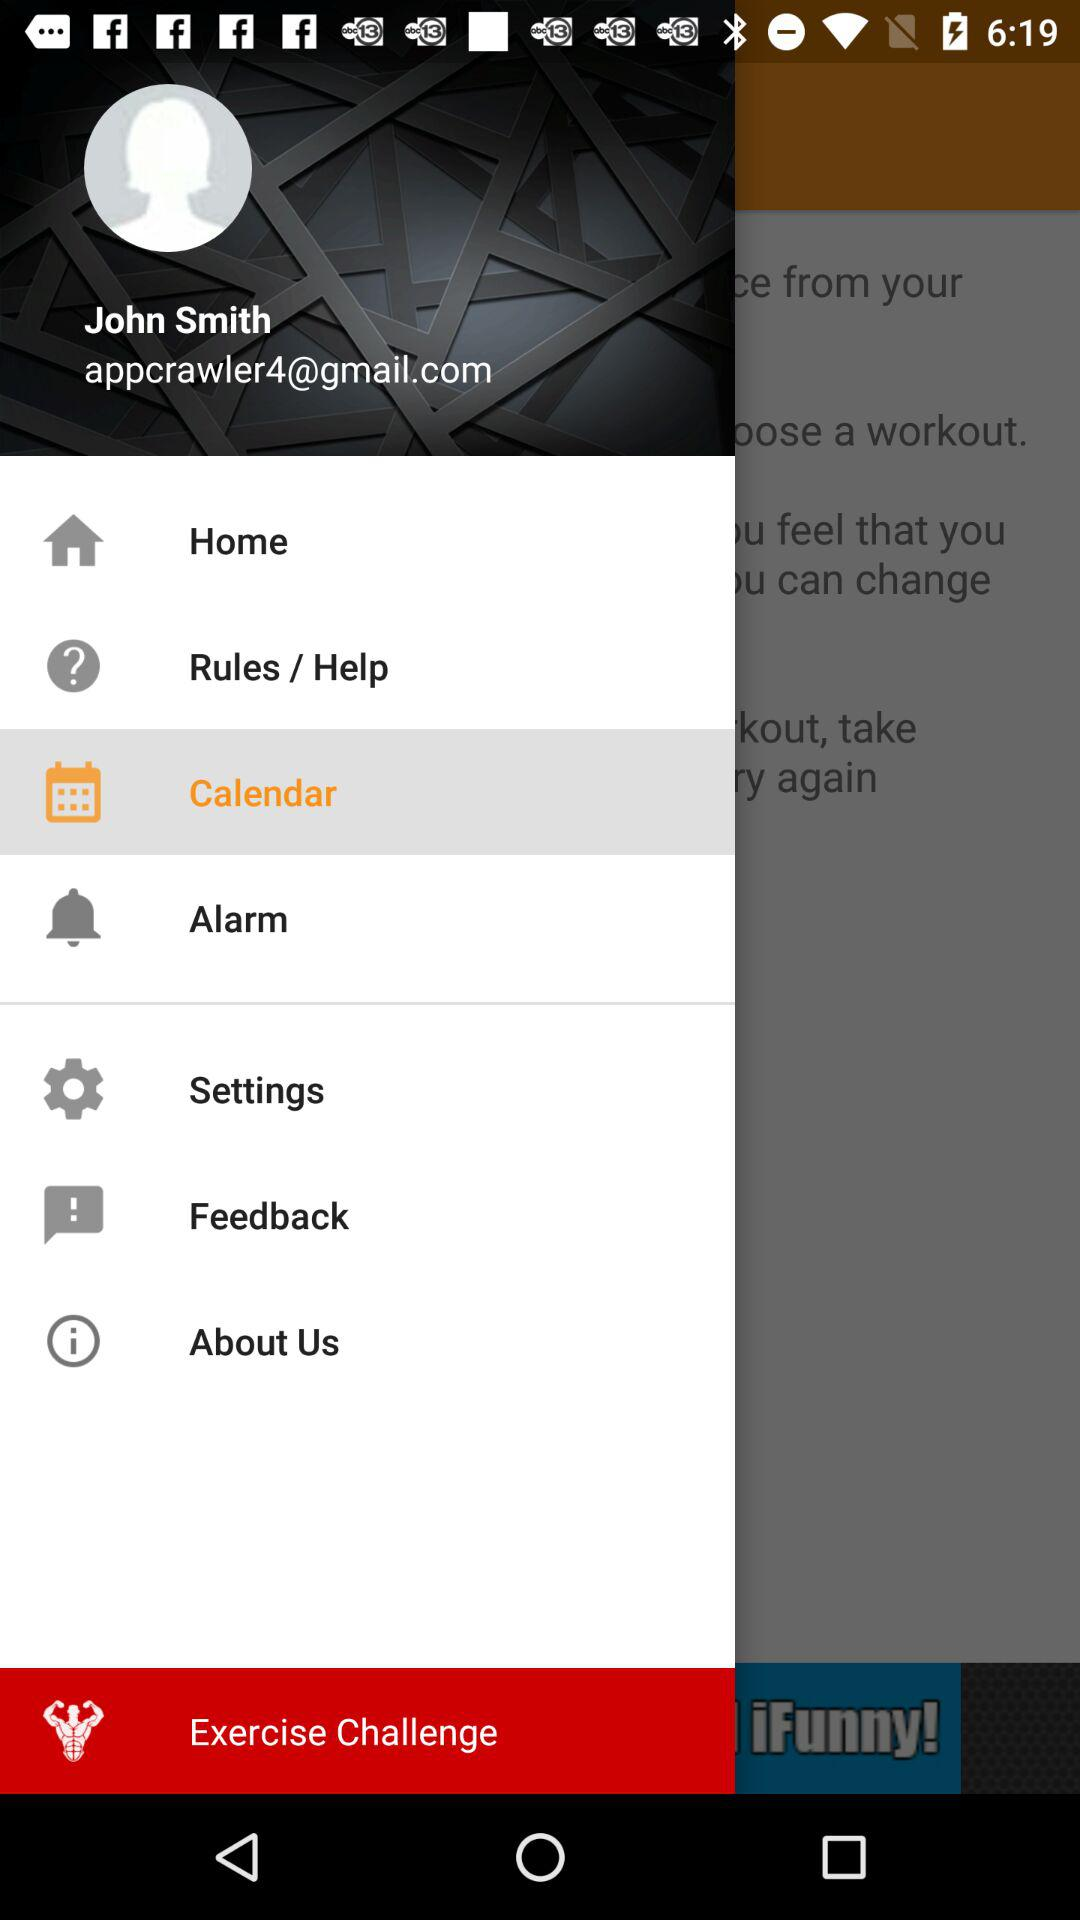Which days are chosen for the alarm?
When the provided information is insufficient, respond with <no answer>. <no answer> 